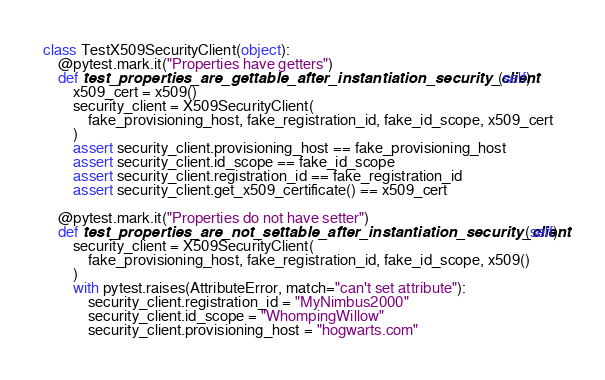Convert code to text. <code><loc_0><loc_0><loc_500><loc_500><_Python_>class TestX509SecurityClient(object):
    @pytest.mark.it("Properties have getters")
    def test_properties_are_gettable_after_instantiation_security_client(self):
        x509_cert = x509()
        security_client = X509SecurityClient(
            fake_provisioning_host, fake_registration_id, fake_id_scope, x509_cert
        )
        assert security_client.provisioning_host == fake_provisioning_host
        assert security_client.id_scope == fake_id_scope
        assert security_client.registration_id == fake_registration_id
        assert security_client.get_x509_certificate() == x509_cert

    @pytest.mark.it("Properties do not have setter")
    def test_properties_are_not_settable_after_instantiation_security_client(self):
        security_client = X509SecurityClient(
            fake_provisioning_host, fake_registration_id, fake_id_scope, x509()
        )
        with pytest.raises(AttributeError, match="can't set attribute"):
            security_client.registration_id = "MyNimbus2000"
            security_client.id_scope = "WhompingWillow"
            security_client.provisioning_host = "hogwarts.com"
</code> 